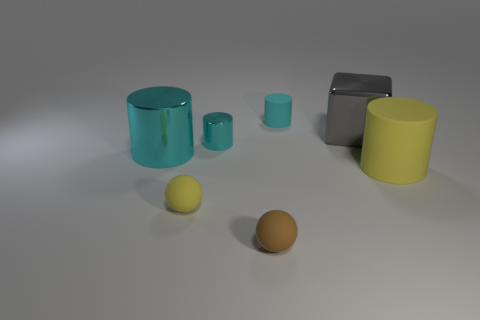Subtract all yellow balls. How many cyan cylinders are left? 3 Subtract all yellow cylinders. How many cylinders are left? 3 Subtract all gray cylinders. Subtract all green spheres. How many cylinders are left? 4 Add 2 large objects. How many objects exist? 9 Subtract all cubes. How many objects are left? 6 Add 1 rubber spheres. How many rubber spheres exist? 3 Subtract 1 yellow cylinders. How many objects are left? 6 Subtract all small green metal cubes. Subtract all big yellow rubber cylinders. How many objects are left? 6 Add 3 big yellow matte objects. How many big yellow matte objects are left? 4 